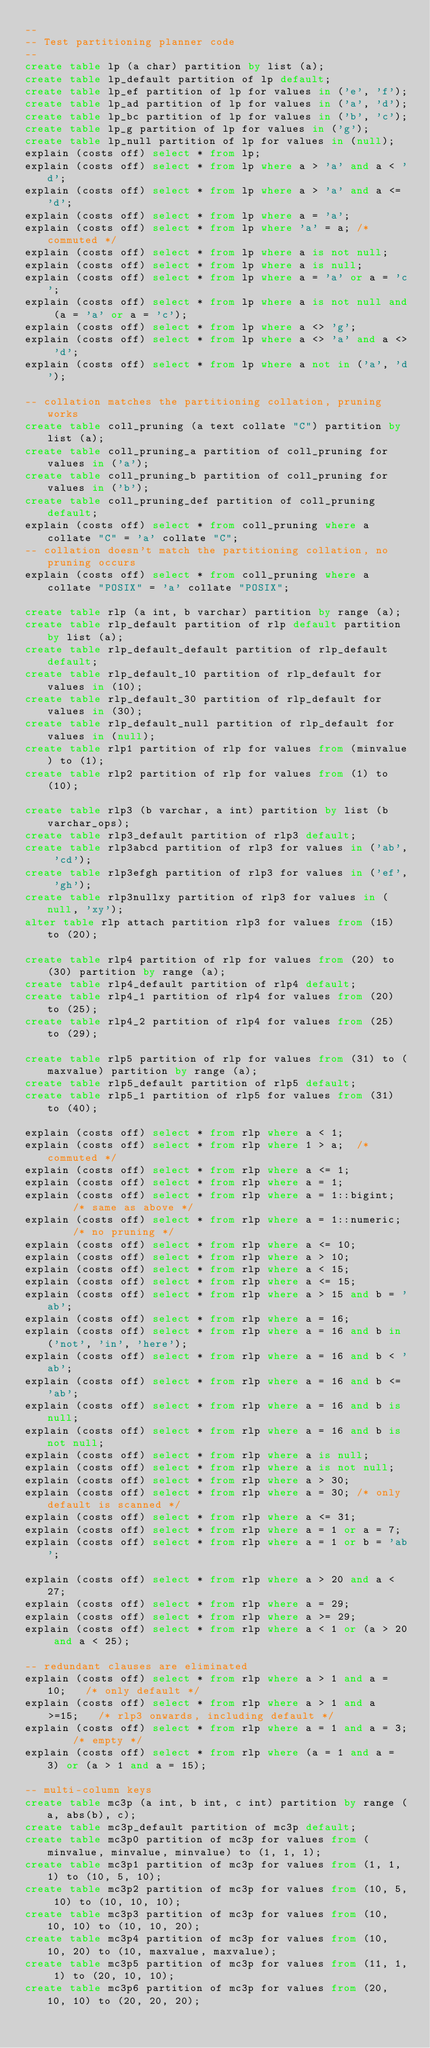<code> <loc_0><loc_0><loc_500><loc_500><_SQL_>--
-- Test partitioning planner code
--
create table lp (a char) partition by list (a);
create table lp_default partition of lp default;
create table lp_ef partition of lp for values in ('e', 'f');
create table lp_ad partition of lp for values in ('a', 'd');
create table lp_bc partition of lp for values in ('b', 'c');
create table lp_g partition of lp for values in ('g');
create table lp_null partition of lp for values in (null);
explain (costs off) select * from lp;
explain (costs off) select * from lp where a > 'a' and a < 'd';
explain (costs off) select * from lp where a > 'a' and a <= 'd';
explain (costs off) select * from lp where a = 'a';
explain (costs off) select * from lp where 'a' = a;	/* commuted */
explain (costs off) select * from lp where a is not null;
explain (costs off) select * from lp where a is null;
explain (costs off) select * from lp where a = 'a' or a = 'c';
explain (costs off) select * from lp where a is not null and (a = 'a' or a = 'c');
explain (costs off) select * from lp where a <> 'g';
explain (costs off) select * from lp where a <> 'a' and a <> 'd';
explain (costs off) select * from lp where a not in ('a', 'd');

-- collation matches the partitioning collation, pruning works
create table coll_pruning (a text collate "C") partition by list (a);
create table coll_pruning_a partition of coll_pruning for values in ('a');
create table coll_pruning_b partition of coll_pruning for values in ('b');
create table coll_pruning_def partition of coll_pruning default;
explain (costs off) select * from coll_pruning where a collate "C" = 'a' collate "C";
-- collation doesn't match the partitioning collation, no pruning occurs
explain (costs off) select * from coll_pruning where a collate "POSIX" = 'a' collate "POSIX";

create table rlp (a int, b varchar) partition by range (a);
create table rlp_default partition of rlp default partition by list (a);
create table rlp_default_default partition of rlp_default default;
create table rlp_default_10 partition of rlp_default for values in (10);
create table rlp_default_30 partition of rlp_default for values in (30);
create table rlp_default_null partition of rlp_default for values in (null);
create table rlp1 partition of rlp for values from (minvalue) to (1);
create table rlp2 partition of rlp for values from (1) to (10);

create table rlp3 (b varchar, a int) partition by list (b varchar_ops);
create table rlp3_default partition of rlp3 default;
create table rlp3abcd partition of rlp3 for values in ('ab', 'cd');
create table rlp3efgh partition of rlp3 for values in ('ef', 'gh');
create table rlp3nullxy partition of rlp3 for values in (null, 'xy');
alter table rlp attach partition rlp3 for values from (15) to (20);

create table rlp4 partition of rlp for values from (20) to (30) partition by range (a);
create table rlp4_default partition of rlp4 default;
create table rlp4_1 partition of rlp4 for values from (20) to (25);
create table rlp4_2 partition of rlp4 for values from (25) to (29);

create table rlp5 partition of rlp for values from (31) to (maxvalue) partition by range (a);
create table rlp5_default partition of rlp5 default;
create table rlp5_1 partition of rlp5 for values from (31) to (40);

explain (costs off) select * from rlp where a < 1;
explain (costs off) select * from rlp where 1 > a;	/* commuted */
explain (costs off) select * from rlp where a <= 1;
explain (costs off) select * from rlp where a = 1;
explain (costs off) select * from rlp where a = 1::bigint;		/* same as above */
explain (costs off) select * from rlp where a = 1::numeric;		/* no pruning */
explain (costs off) select * from rlp where a <= 10;
explain (costs off) select * from rlp where a > 10;
explain (costs off) select * from rlp where a < 15;
explain (costs off) select * from rlp where a <= 15;
explain (costs off) select * from rlp where a > 15 and b = 'ab';
explain (costs off) select * from rlp where a = 16;
explain (costs off) select * from rlp where a = 16 and b in ('not', 'in', 'here');
explain (costs off) select * from rlp where a = 16 and b < 'ab';
explain (costs off) select * from rlp where a = 16 and b <= 'ab';
explain (costs off) select * from rlp where a = 16 and b is null;
explain (costs off) select * from rlp where a = 16 and b is not null;
explain (costs off) select * from rlp where a is null;
explain (costs off) select * from rlp where a is not null;
explain (costs off) select * from rlp where a > 30;
explain (costs off) select * from rlp where a = 30;	/* only default is scanned */
explain (costs off) select * from rlp where a <= 31;
explain (costs off) select * from rlp where a = 1 or a = 7;
explain (costs off) select * from rlp where a = 1 or b = 'ab';

explain (costs off) select * from rlp where a > 20 and a < 27;
explain (costs off) select * from rlp where a = 29;
explain (costs off) select * from rlp where a >= 29;
explain (costs off) select * from rlp where a < 1 or (a > 20 and a < 25);

-- redundant clauses are eliminated
explain (costs off) select * from rlp where a > 1 and a = 10;	/* only default */
explain (costs off) select * from rlp where a > 1 and a >=15;	/* rlp3 onwards, including default */
explain (costs off) select * from rlp where a = 1 and a = 3;	/* empty */
explain (costs off) select * from rlp where (a = 1 and a = 3) or (a > 1 and a = 15);

-- multi-column keys
create table mc3p (a int, b int, c int) partition by range (a, abs(b), c);
create table mc3p_default partition of mc3p default;
create table mc3p0 partition of mc3p for values from (minvalue, minvalue, minvalue) to (1, 1, 1);
create table mc3p1 partition of mc3p for values from (1, 1, 1) to (10, 5, 10);
create table mc3p2 partition of mc3p for values from (10, 5, 10) to (10, 10, 10);
create table mc3p3 partition of mc3p for values from (10, 10, 10) to (10, 10, 20);
create table mc3p4 partition of mc3p for values from (10, 10, 20) to (10, maxvalue, maxvalue);
create table mc3p5 partition of mc3p for values from (11, 1, 1) to (20, 10, 10);
create table mc3p6 partition of mc3p for values from (20, 10, 10) to (20, 20, 20);</code> 